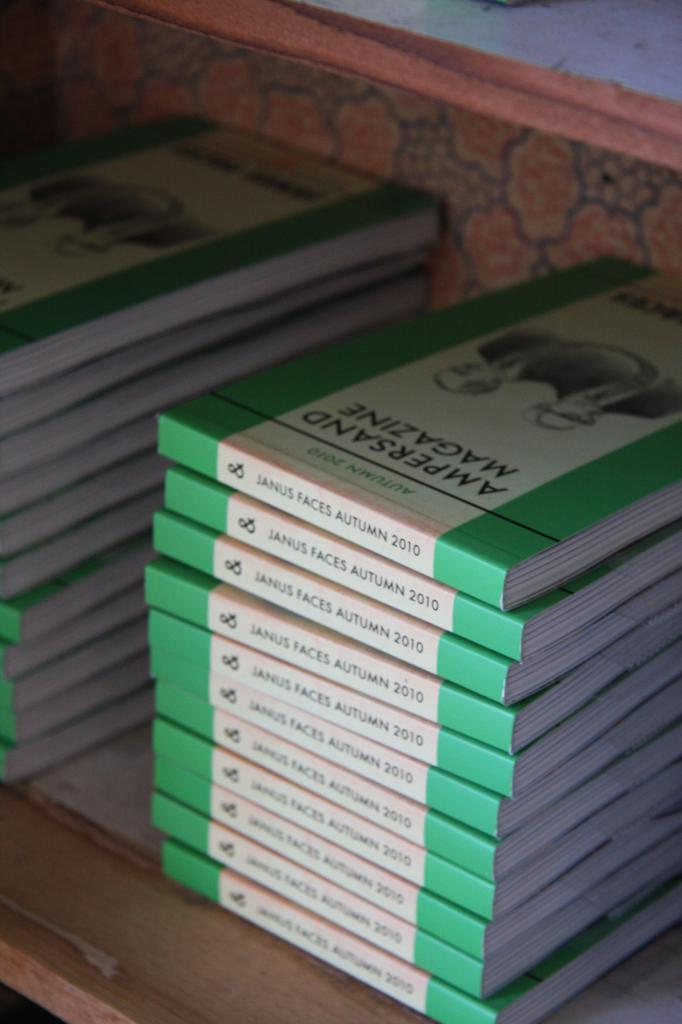What objects are on the table in the image? There are books on a table in the image. Can you describe anything in the background of the image? There is a cloth-like object in the background of the image. What type of music is the band playing in the background of the image? There is no band present in the image, so it is not possible to determine what type of music they might be playing. 